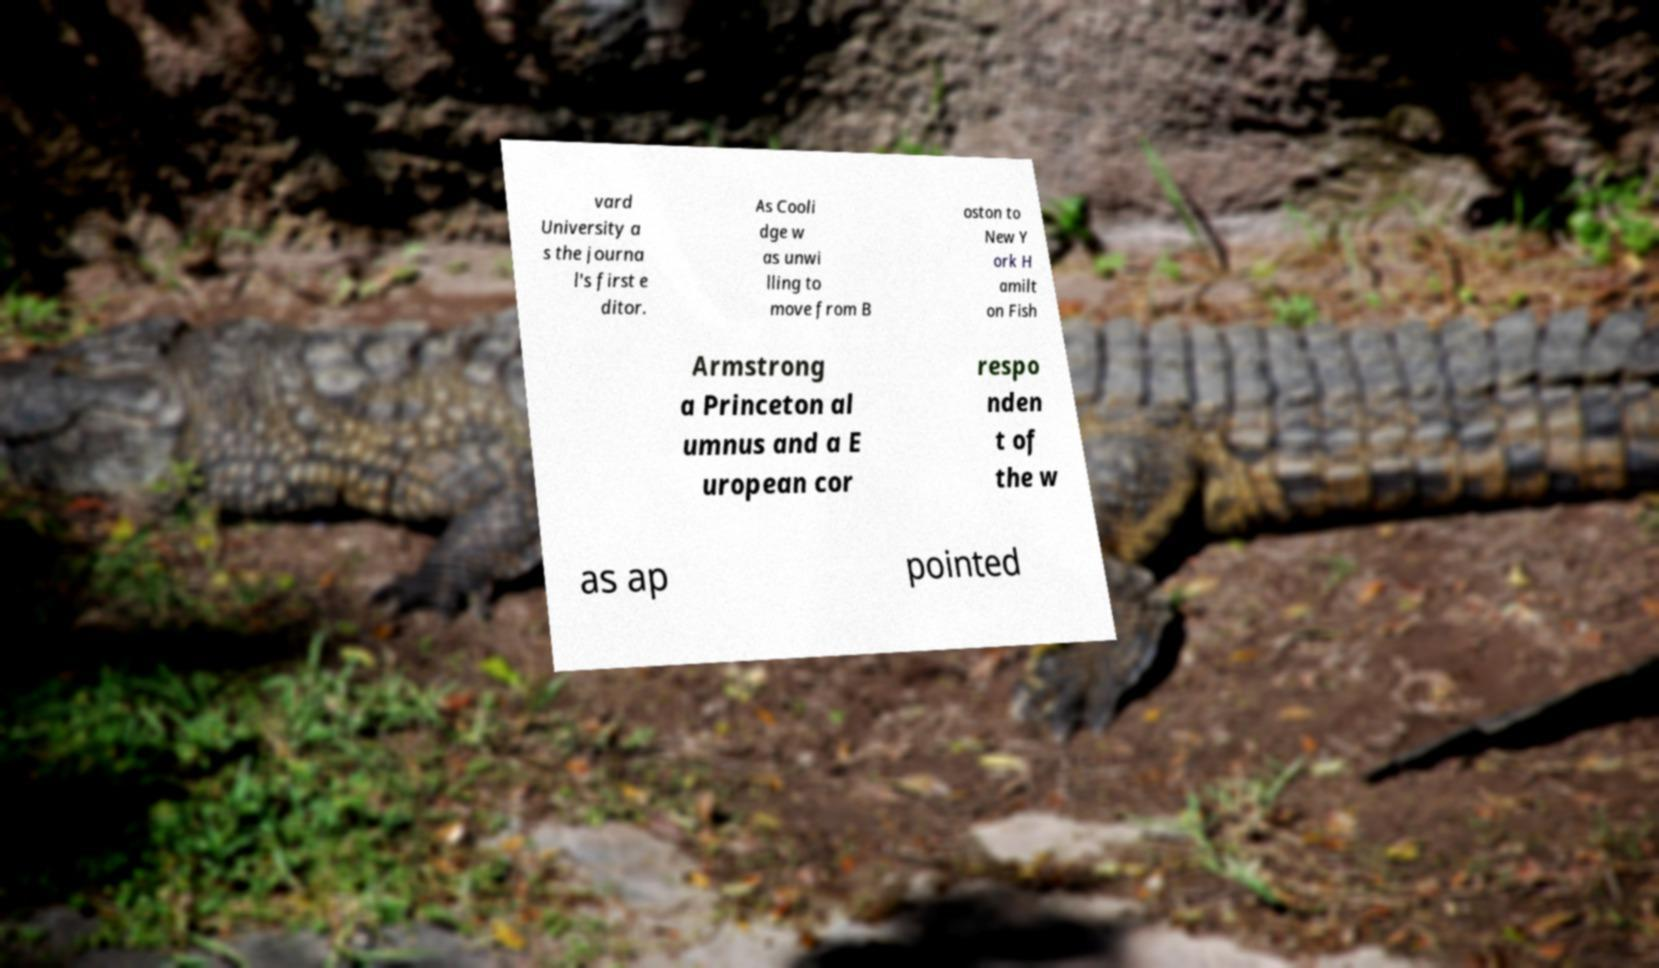There's text embedded in this image that I need extracted. Can you transcribe it verbatim? vard University a s the journa l's first e ditor. As Cooli dge w as unwi lling to move from B oston to New Y ork H amilt on Fish Armstrong a Princeton al umnus and a E uropean cor respo nden t of the w as ap pointed 